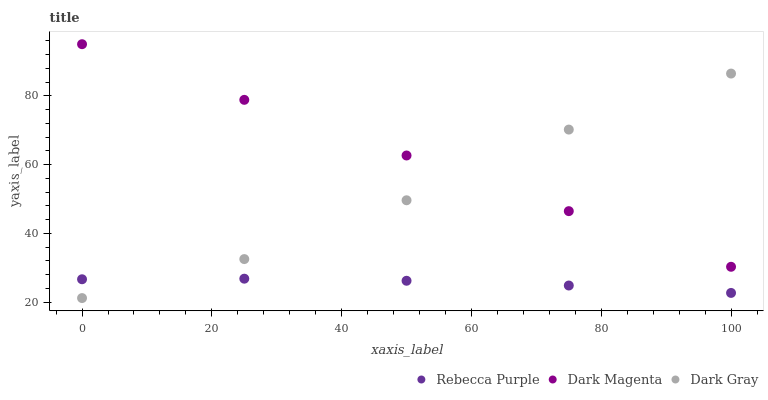Does Rebecca Purple have the minimum area under the curve?
Answer yes or no. Yes. Does Dark Magenta have the maximum area under the curve?
Answer yes or no. Yes. Does Dark Magenta have the minimum area under the curve?
Answer yes or no. No. Does Rebecca Purple have the maximum area under the curve?
Answer yes or no. No. Is Dark Magenta the smoothest?
Answer yes or no. Yes. Is Dark Gray the roughest?
Answer yes or no. Yes. Is Rebecca Purple the smoothest?
Answer yes or no. No. Is Rebecca Purple the roughest?
Answer yes or no. No. Does Dark Gray have the lowest value?
Answer yes or no. Yes. Does Rebecca Purple have the lowest value?
Answer yes or no. No. Does Dark Magenta have the highest value?
Answer yes or no. Yes. Does Rebecca Purple have the highest value?
Answer yes or no. No. Is Rebecca Purple less than Dark Magenta?
Answer yes or no. Yes. Is Dark Magenta greater than Rebecca Purple?
Answer yes or no. Yes. Does Dark Gray intersect Dark Magenta?
Answer yes or no. Yes. Is Dark Gray less than Dark Magenta?
Answer yes or no. No. Is Dark Gray greater than Dark Magenta?
Answer yes or no. No. Does Rebecca Purple intersect Dark Magenta?
Answer yes or no. No. 